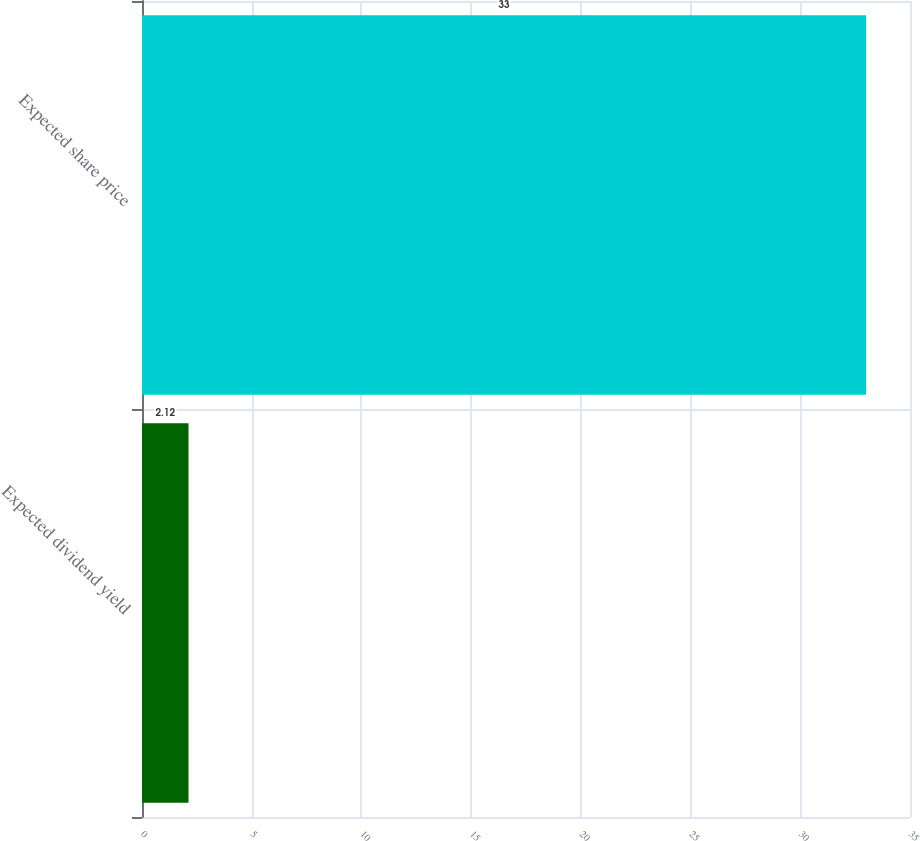Convert chart to OTSL. <chart><loc_0><loc_0><loc_500><loc_500><bar_chart><fcel>Expected dividend yield<fcel>Expected share price<nl><fcel>2.12<fcel>33<nl></chart> 